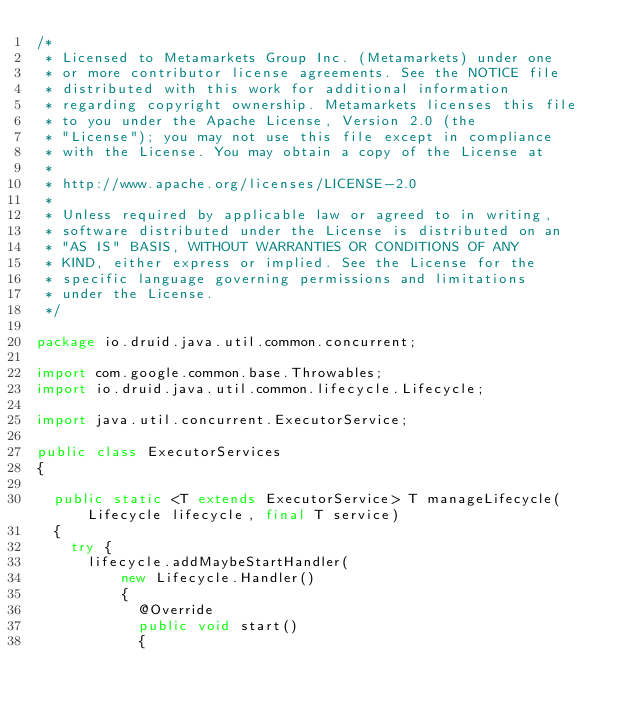Convert code to text. <code><loc_0><loc_0><loc_500><loc_500><_Java_>/*
 * Licensed to Metamarkets Group Inc. (Metamarkets) under one
 * or more contributor license agreements. See the NOTICE file
 * distributed with this work for additional information
 * regarding copyright ownership. Metamarkets licenses this file
 * to you under the Apache License, Version 2.0 (the
 * "License"); you may not use this file except in compliance
 * with the License. You may obtain a copy of the License at
 *
 * http://www.apache.org/licenses/LICENSE-2.0
 *
 * Unless required by applicable law or agreed to in writing,
 * software distributed under the License is distributed on an
 * "AS IS" BASIS, WITHOUT WARRANTIES OR CONDITIONS OF ANY
 * KIND, either express or implied. See the License for the
 * specific language governing permissions and limitations
 * under the License.
 */

package io.druid.java.util.common.concurrent;

import com.google.common.base.Throwables;
import io.druid.java.util.common.lifecycle.Lifecycle;

import java.util.concurrent.ExecutorService;

public class ExecutorServices
{

  public static <T extends ExecutorService> T manageLifecycle(Lifecycle lifecycle, final T service)
  {
    try {
      lifecycle.addMaybeStartHandler(
          new Lifecycle.Handler()
          {
            @Override
            public void start()
            {</code> 